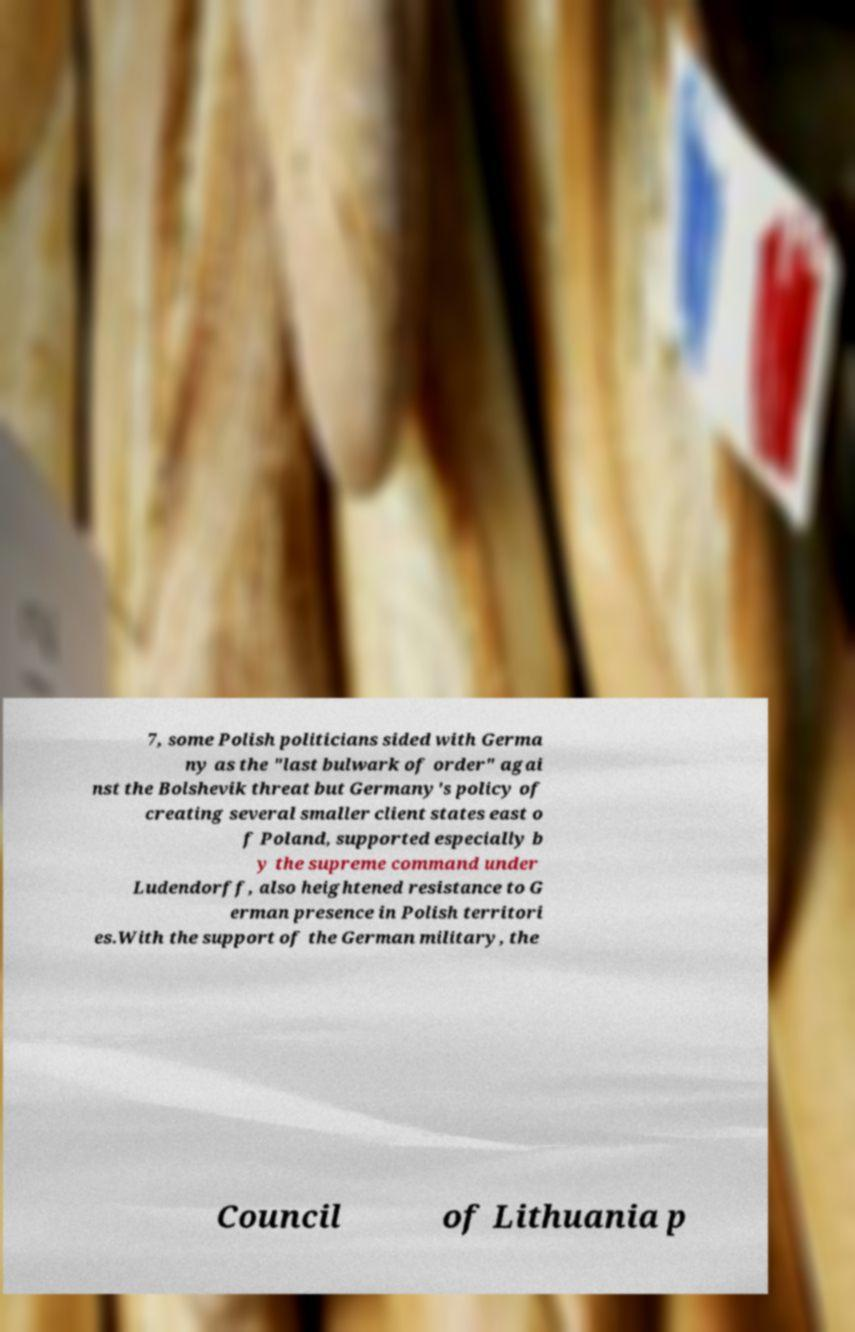Could you assist in decoding the text presented in this image and type it out clearly? 7, some Polish politicians sided with Germa ny as the "last bulwark of order" agai nst the Bolshevik threat but Germany's policy of creating several smaller client states east o f Poland, supported especially b y the supreme command under Ludendorff, also heightened resistance to G erman presence in Polish territori es.With the support of the German military, the Council of Lithuania p 